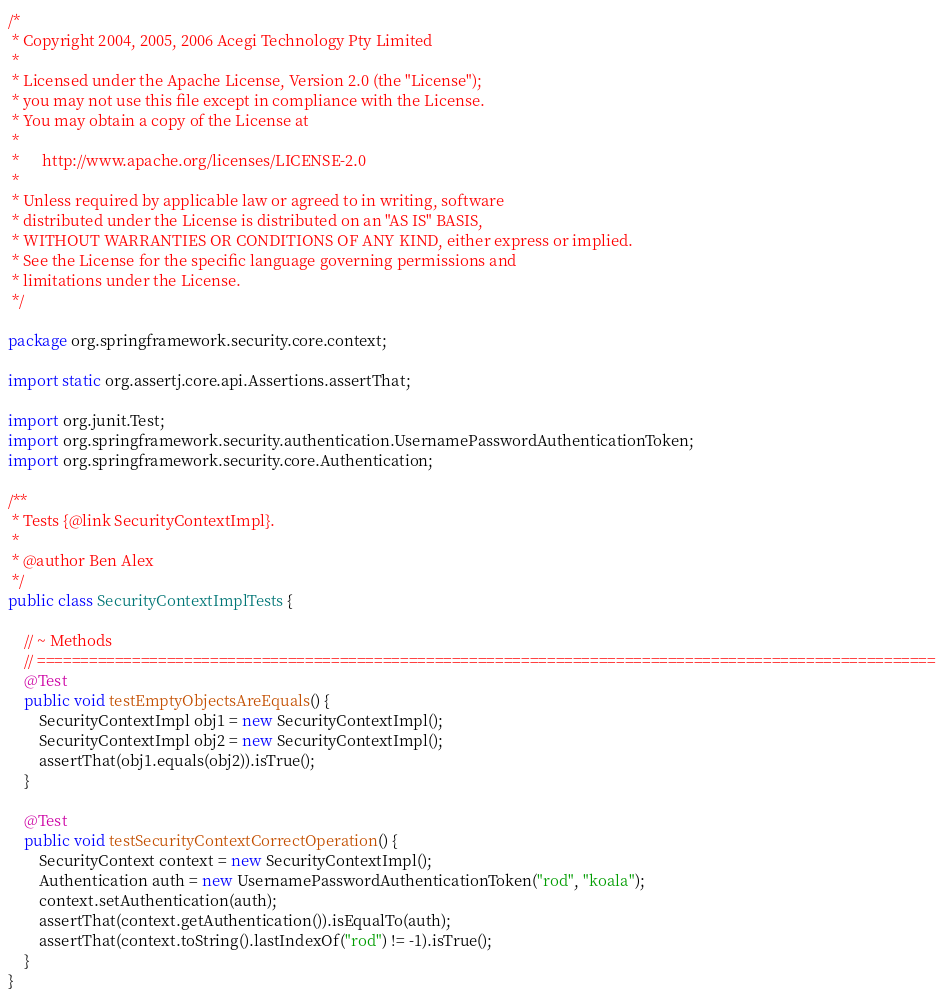<code> <loc_0><loc_0><loc_500><loc_500><_Java_>/*
 * Copyright 2004, 2005, 2006 Acegi Technology Pty Limited
 *
 * Licensed under the Apache License, Version 2.0 (the "License");
 * you may not use this file except in compliance with the License.
 * You may obtain a copy of the License at
 *
 *      http://www.apache.org/licenses/LICENSE-2.0
 *
 * Unless required by applicable law or agreed to in writing, software
 * distributed under the License is distributed on an "AS IS" BASIS,
 * WITHOUT WARRANTIES OR CONDITIONS OF ANY KIND, either express or implied.
 * See the License for the specific language governing permissions and
 * limitations under the License.
 */

package org.springframework.security.core.context;

import static org.assertj.core.api.Assertions.assertThat;

import org.junit.Test;
import org.springframework.security.authentication.UsernamePasswordAuthenticationToken;
import org.springframework.security.core.Authentication;

/**
 * Tests {@link SecurityContextImpl}.
 *
 * @author Ben Alex
 */
public class SecurityContextImplTests {

	// ~ Methods
	// ========================================================================================================
	@Test
	public void testEmptyObjectsAreEquals() {
		SecurityContextImpl obj1 = new SecurityContextImpl();
		SecurityContextImpl obj2 = new SecurityContextImpl();
		assertThat(obj1.equals(obj2)).isTrue();
	}

	@Test
	public void testSecurityContextCorrectOperation() {
		SecurityContext context = new SecurityContextImpl();
		Authentication auth = new UsernamePasswordAuthenticationToken("rod", "koala");
		context.setAuthentication(auth);
		assertThat(context.getAuthentication()).isEqualTo(auth);
		assertThat(context.toString().lastIndexOf("rod") != -1).isTrue();
	}
}
</code> 